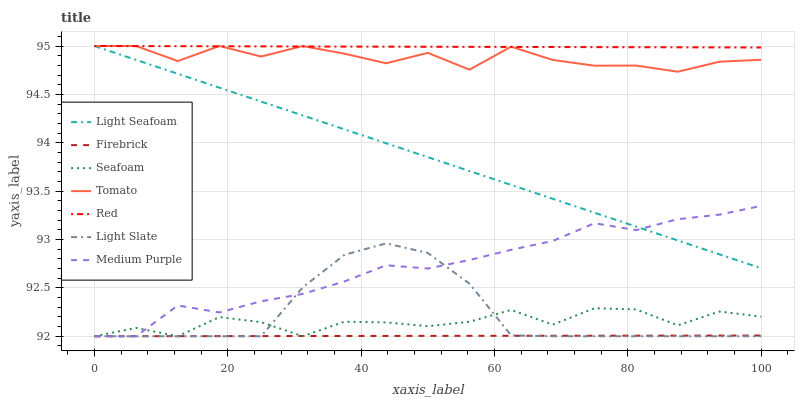Does Firebrick have the minimum area under the curve?
Answer yes or no. Yes. Does Red have the maximum area under the curve?
Answer yes or no. Yes. Does Light Slate have the minimum area under the curve?
Answer yes or no. No. Does Light Slate have the maximum area under the curve?
Answer yes or no. No. Is Light Seafoam the smoothest?
Answer yes or no. Yes. Is Tomato the roughest?
Answer yes or no. Yes. Is Light Slate the smoothest?
Answer yes or no. No. Is Light Slate the roughest?
Answer yes or no. No. Does Light Seafoam have the lowest value?
Answer yes or no. No. Does Red have the highest value?
Answer yes or no. Yes. Does Light Slate have the highest value?
Answer yes or no. No. Is Firebrick less than Red?
Answer yes or no. Yes. Is Tomato greater than Firebrick?
Answer yes or no. Yes. Does Red intersect Light Seafoam?
Answer yes or no. Yes. Is Red less than Light Seafoam?
Answer yes or no. No. Is Red greater than Light Seafoam?
Answer yes or no. No. Does Firebrick intersect Red?
Answer yes or no. No. 